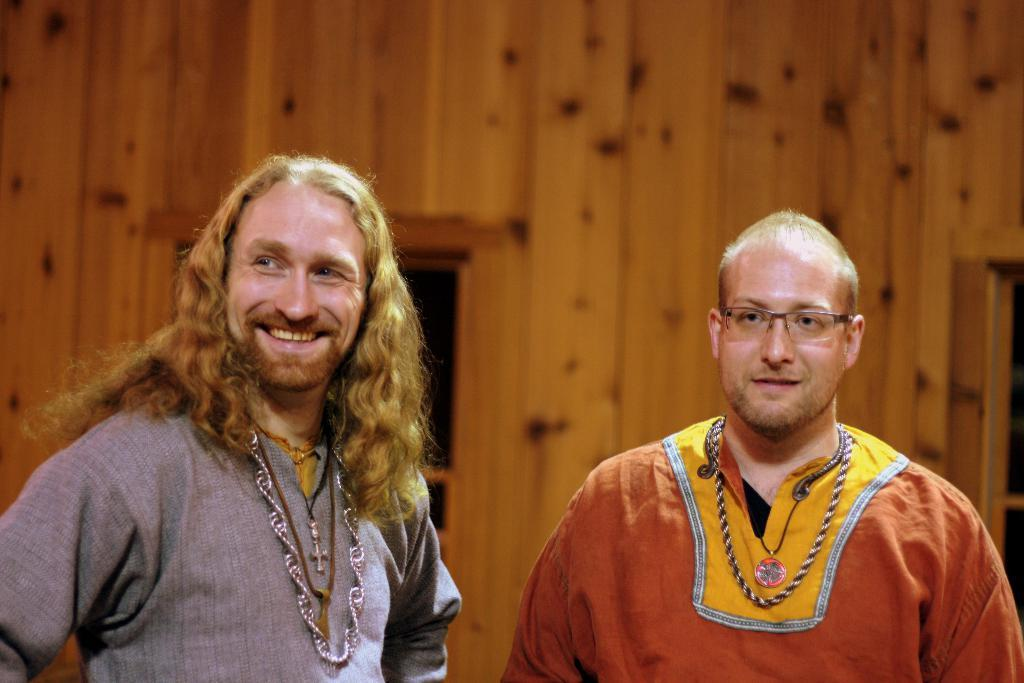How many people are in the image? There are two men in the image. What expression do the men have in the image? The men are smiling in the image. What can be seen in the background of the image? There is a wall and a window in the background of the image. What type of butter is being used to measure the flag in the image? There is no butter or flag present in the image. 